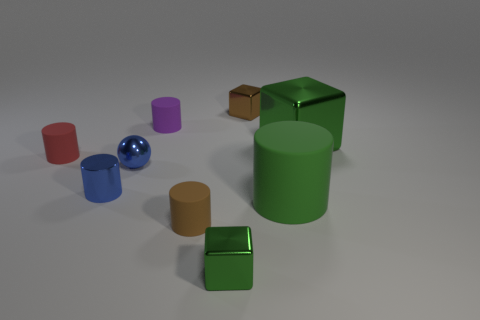Subtract all brown blocks. How many blocks are left? 2 Subtract all gray cylinders. How many green cubes are left? 2 Subtract 1 cubes. How many cubes are left? 2 Subtract all cylinders. How many objects are left? 4 Add 1 small brown metal cylinders. How many objects exist? 10 Subtract all purple cylinders. How many cylinders are left? 4 Subtract all brown cylinders. Subtract all blue balls. How many cylinders are left? 4 Add 9 green cylinders. How many green cylinders exist? 10 Subtract 0 blue blocks. How many objects are left? 9 Subtract all large purple matte objects. Subtract all blue shiny spheres. How many objects are left? 8 